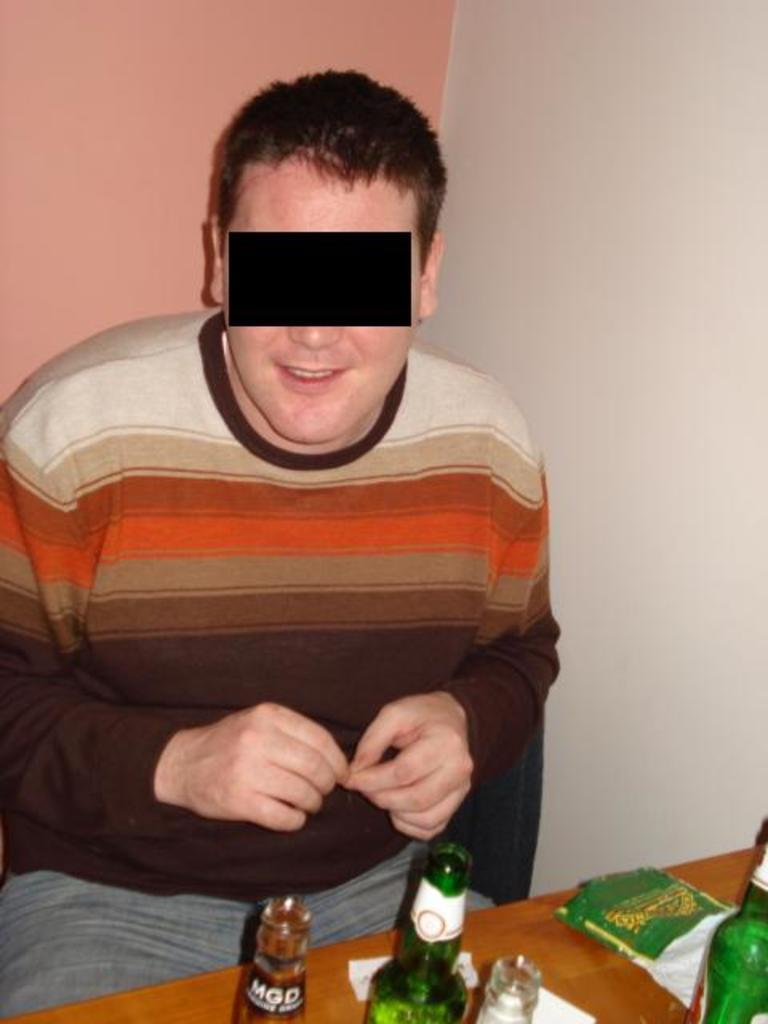What type of setting is depicted in the image? The image is of an indoor setting. Who or what is in the center of the image? There is a man sitting in the center of the image. What furniture piece can be seen in the image? There is a table in the image. What items are placed on the table? Bottles are placed on the table. What can be seen in the background of the image? There is a wall visible in the background of the image. What type of fuel is being used to power the wax candles in the image? There are no wax candles present in the image, so it is not possible to determine the type of fuel being used. 